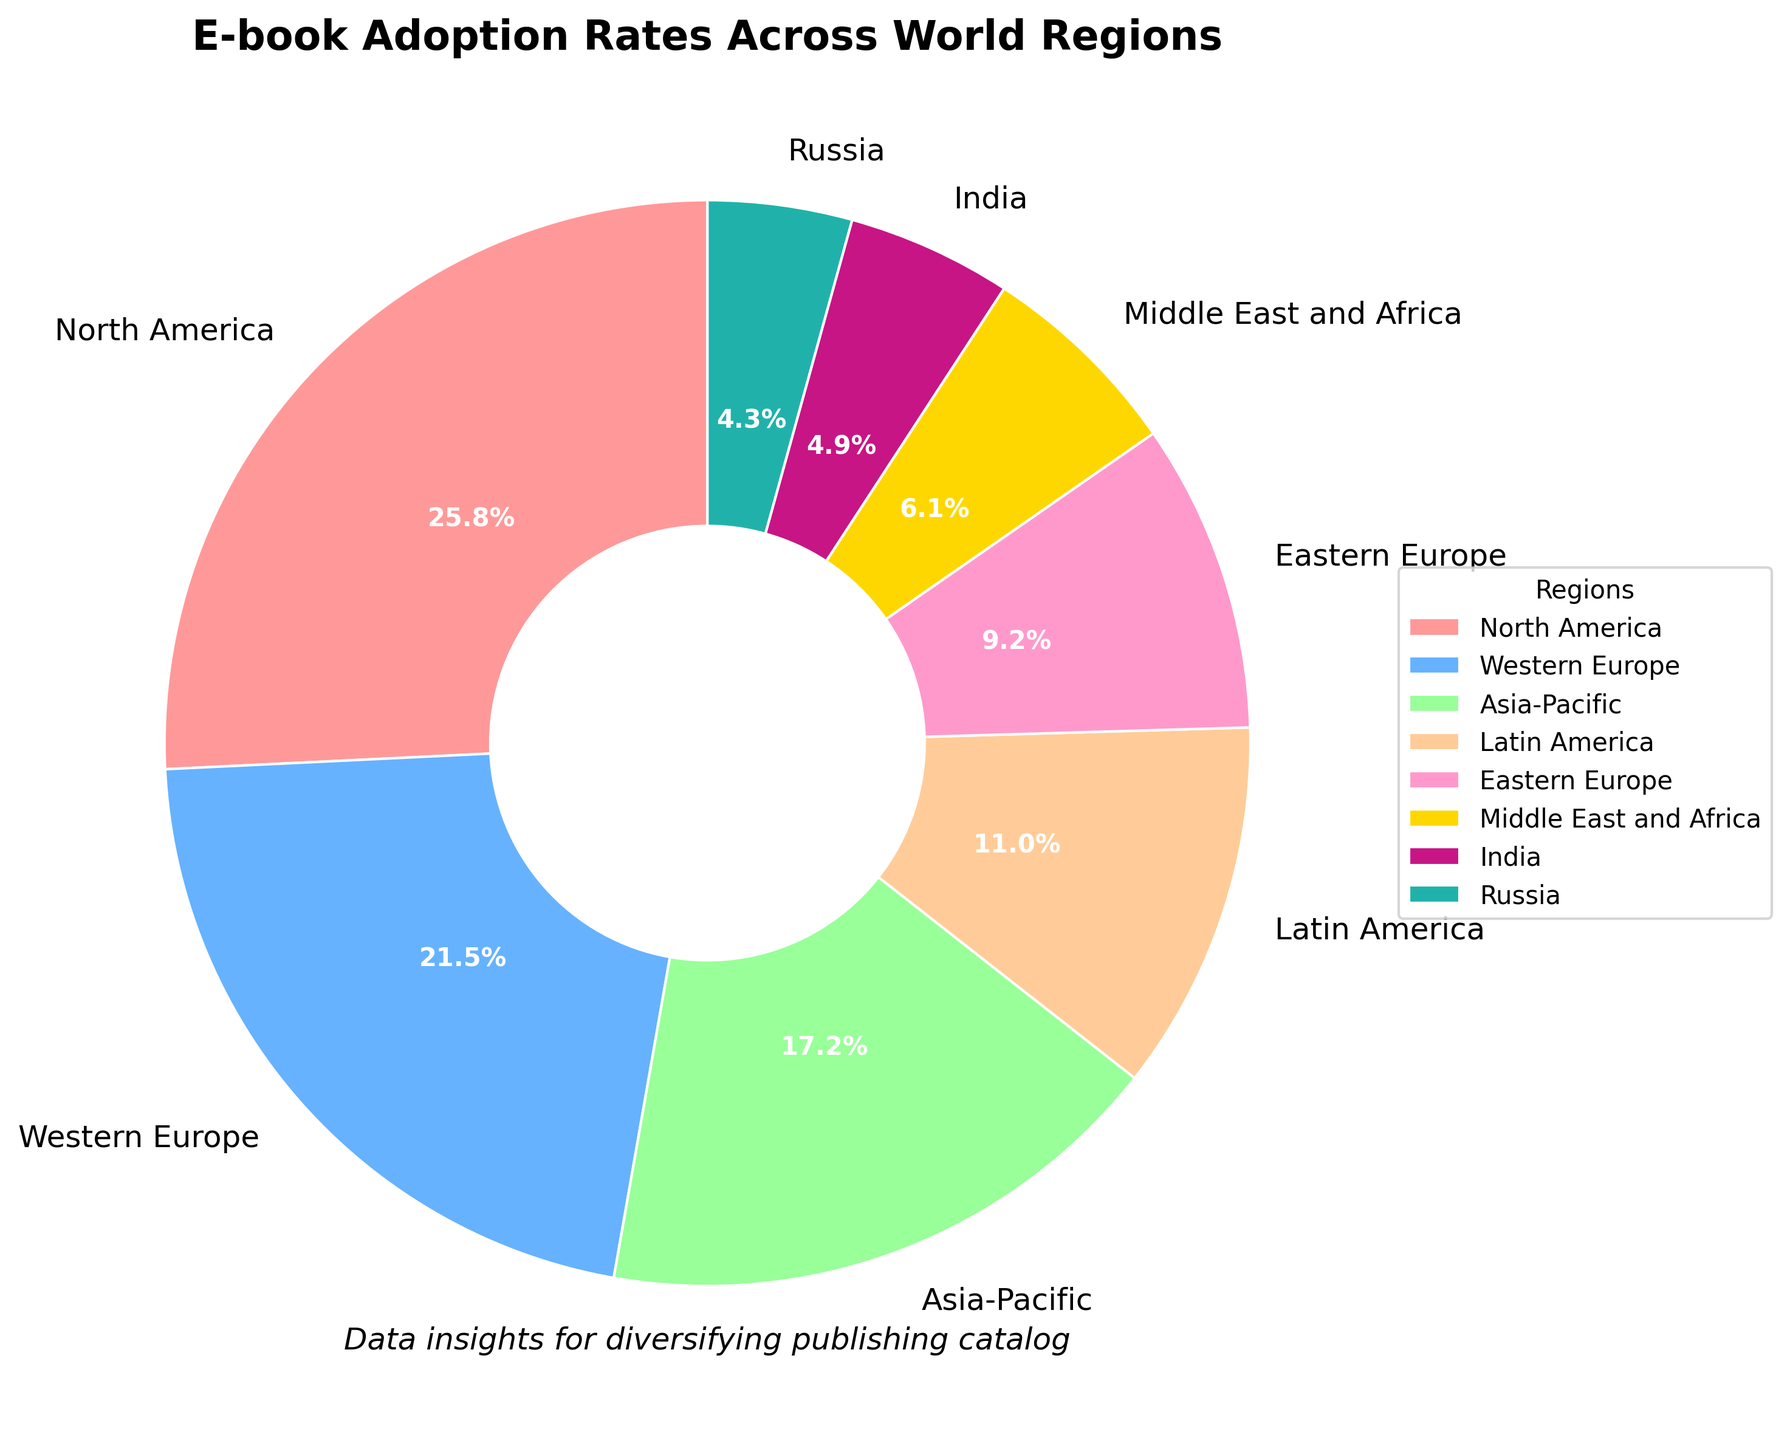Which region has the highest e-book adoption rate? North America has the highest percentage on the pie chart.
Answer: North America Which region has the lowest e-book adoption rate? The region with the smallest percentage on the pie chart is India.
Answer: India What is the difference in e-book adoption rates between North America and Eastern Europe? North America's adoption rate is 42%, and Eastern Europe's rate is 15%. The difference is 42% - 15% = 27%.
Answer: 27% Which regions have an adoption rate greater than 20%? The regions with percentages above 20% on the pie chart are North America (42%), Western Europe (35%), and Asia-Pacific (28%).
Answer: North America, Western Europe, Asia-Pacific What is the adoption rate for the Middle East and Africa combined with Russia? The pie chart shows 10% for the Middle East and Africa and 7% for Russia. The combined rate is 10% + 7% = 17%.
Answer: 17% How much greater is the e-book adoption rate in Western Europe than in India? Western Europe's adoption rate is 35%, while India's is 8%. The difference is 35% - 8% = 27%.
Answer: 27% What percentage of the total e-book adoption is from Latin America, Eastern Europe, and India combined? Latin America (18%), Eastern Europe (15%), and India (8%) sum up to 18% + 15% + 8% = 41%.
Answer: 41% What color represents Asia-Pacific on the pie chart? Asia-Pacific is represented by the green section on the pie chart.
Answer: Green Which two regions have the most similar e-book adoption rates? The pie chart shows Russia (7%) and India (8%) with very close percentages.
Answer: Russia and India Is the adoption rate in Western Europe nearly double that of Eastern Europe? Western Europe has an adoption rate of 35%, and Eastern Europe has 15%. Doubling Eastern Europe's rate gives 15% * 2 = 30%, which is less than Western Europe's 35%.
Answer: No 